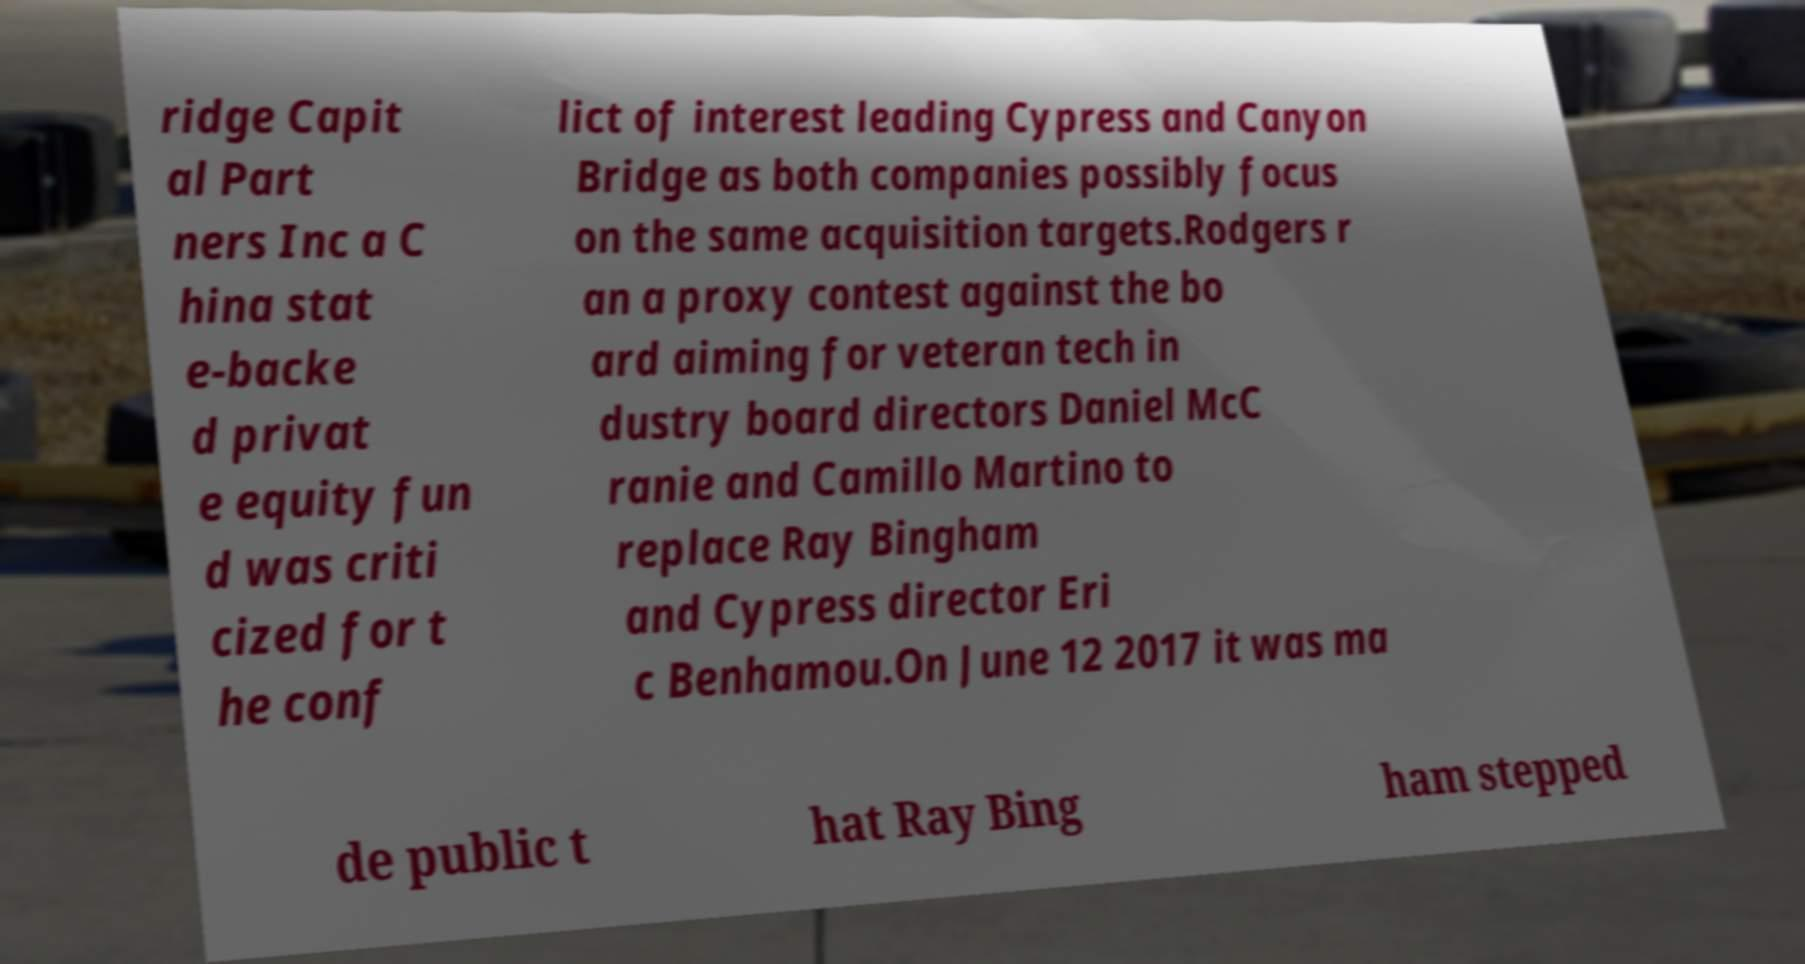Can you read and provide the text displayed in the image?This photo seems to have some interesting text. Can you extract and type it out for me? ridge Capit al Part ners Inc a C hina stat e-backe d privat e equity fun d was criti cized for t he conf lict of interest leading Cypress and Canyon Bridge as both companies possibly focus on the same acquisition targets.Rodgers r an a proxy contest against the bo ard aiming for veteran tech in dustry board directors Daniel McC ranie and Camillo Martino to replace Ray Bingham and Cypress director Eri c Benhamou.On June 12 2017 it was ma de public t hat Ray Bing ham stepped 